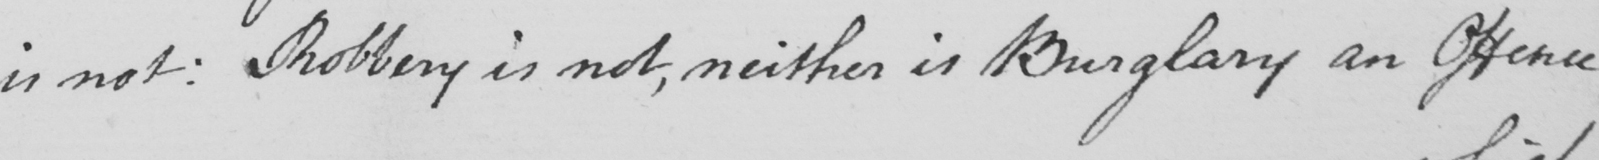What is written in this line of handwriting? is not :  Robbery is not , neither is Burglary an Offence 